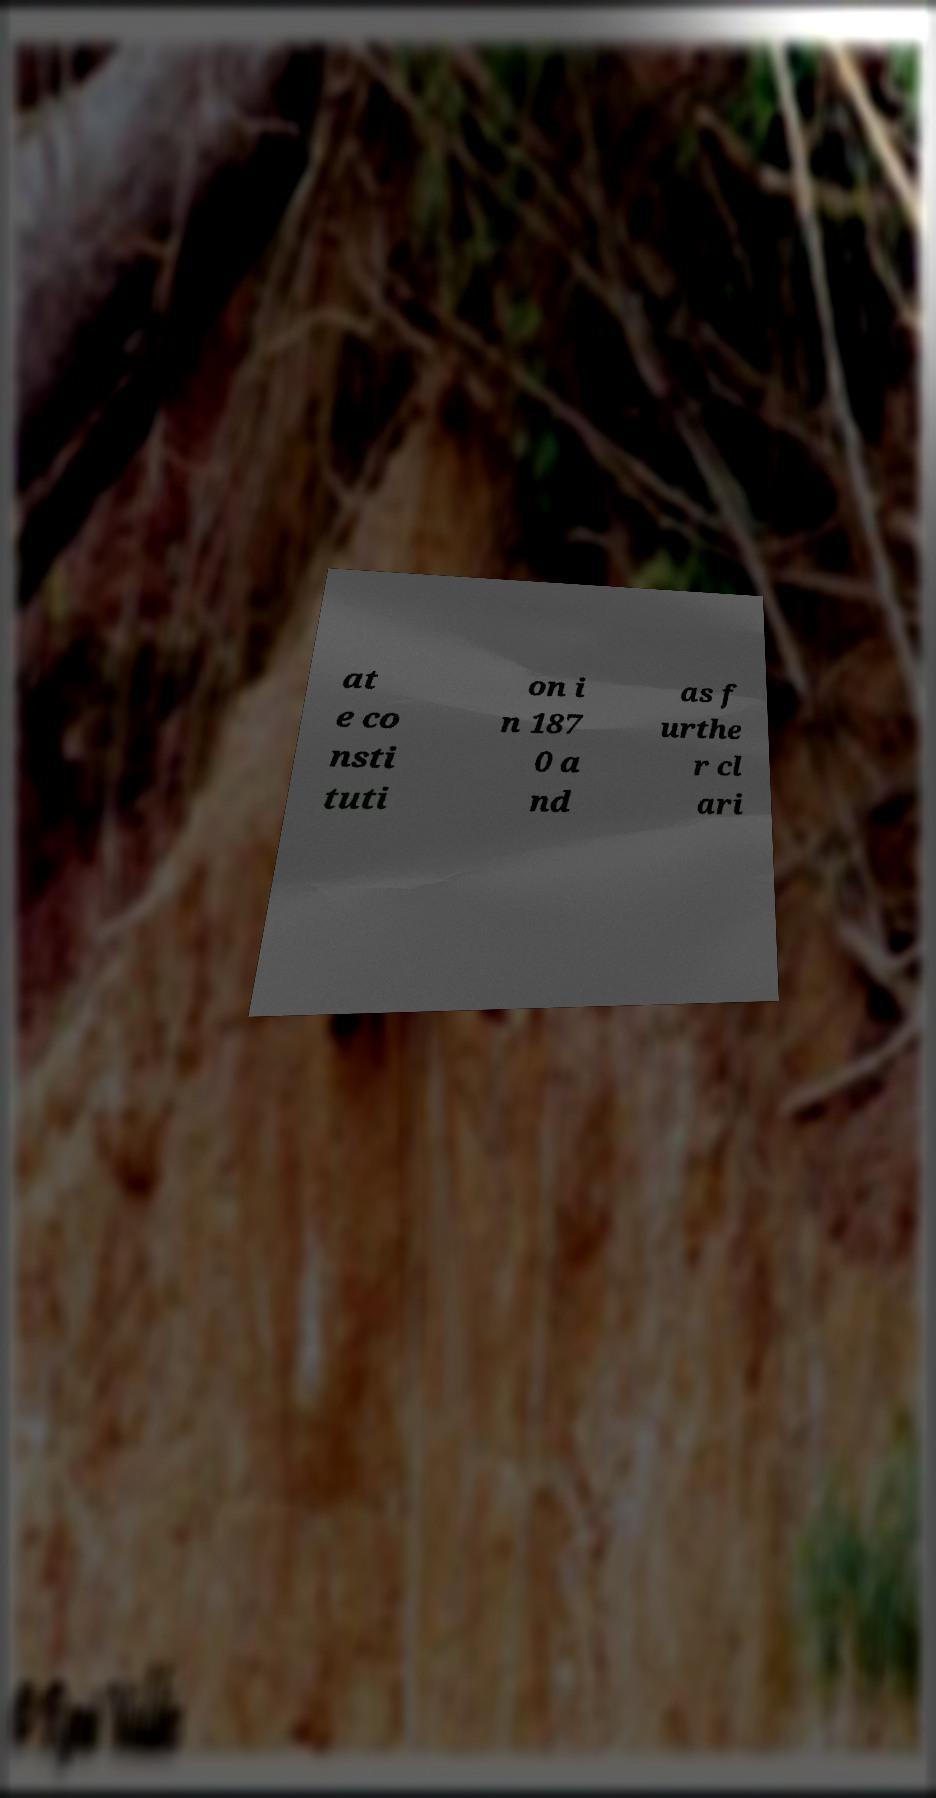Could you assist in decoding the text presented in this image and type it out clearly? at e co nsti tuti on i n 187 0 a nd as f urthe r cl ari 